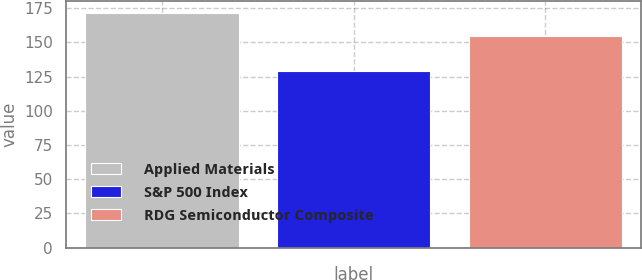Convert chart to OTSL. <chart><loc_0><loc_0><loc_500><loc_500><bar_chart><fcel>Applied Materials<fcel>S&P 500 Index<fcel>RDG Semiconductor Composite<nl><fcel>171.69<fcel>128.93<fcel>154.41<nl></chart> 